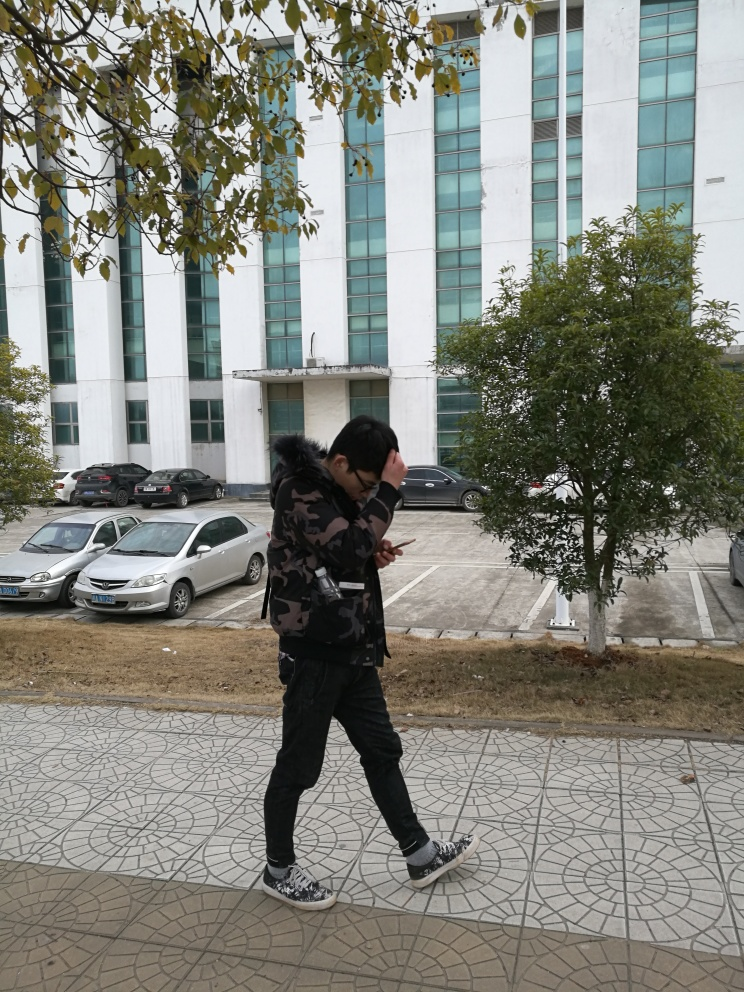What is the weather like in this image? The sky appears overcast with no visible shadows, indicating that it could be a cloudy day. The person is wearing a jacket, suggesting it's likely to be cool. What could be the purpose of the building in the background? The building has a formal design with a stark white facade, possibly indicating a commercial or government use rather than residential. 